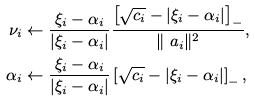<formula> <loc_0><loc_0><loc_500><loc_500>\nu _ { i } & \leftarrow \frac { \xi _ { i } - \alpha _ { i } } { | \xi _ { i } - \alpha _ { i } | } \frac { \left [ \sqrt { c _ { i } } - | \xi _ { i } - \alpha _ { i } | \right ] _ { - } } { \| \ a _ { i } \| ^ { 2 } } , \\ \alpha _ { i } & \leftarrow \frac { \xi _ { i } - \alpha _ { i } } { | \xi _ { i } - \alpha _ { i } | } \left [ \sqrt { c _ { i } } - | \xi _ { i } - \alpha _ { i } | \right ] _ { - } ,</formula> 